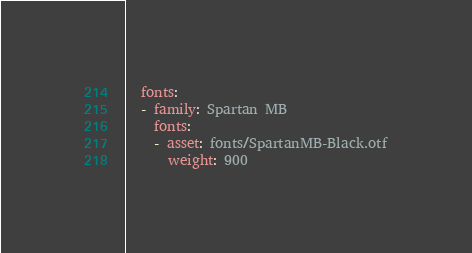<code> <loc_0><loc_0><loc_500><loc_500><_YAML_>  fonts:
  - family: Spartan MB
    fonts:
    - asset: fonts/SpartanMB-Black.otf
      weight: 900</code> 